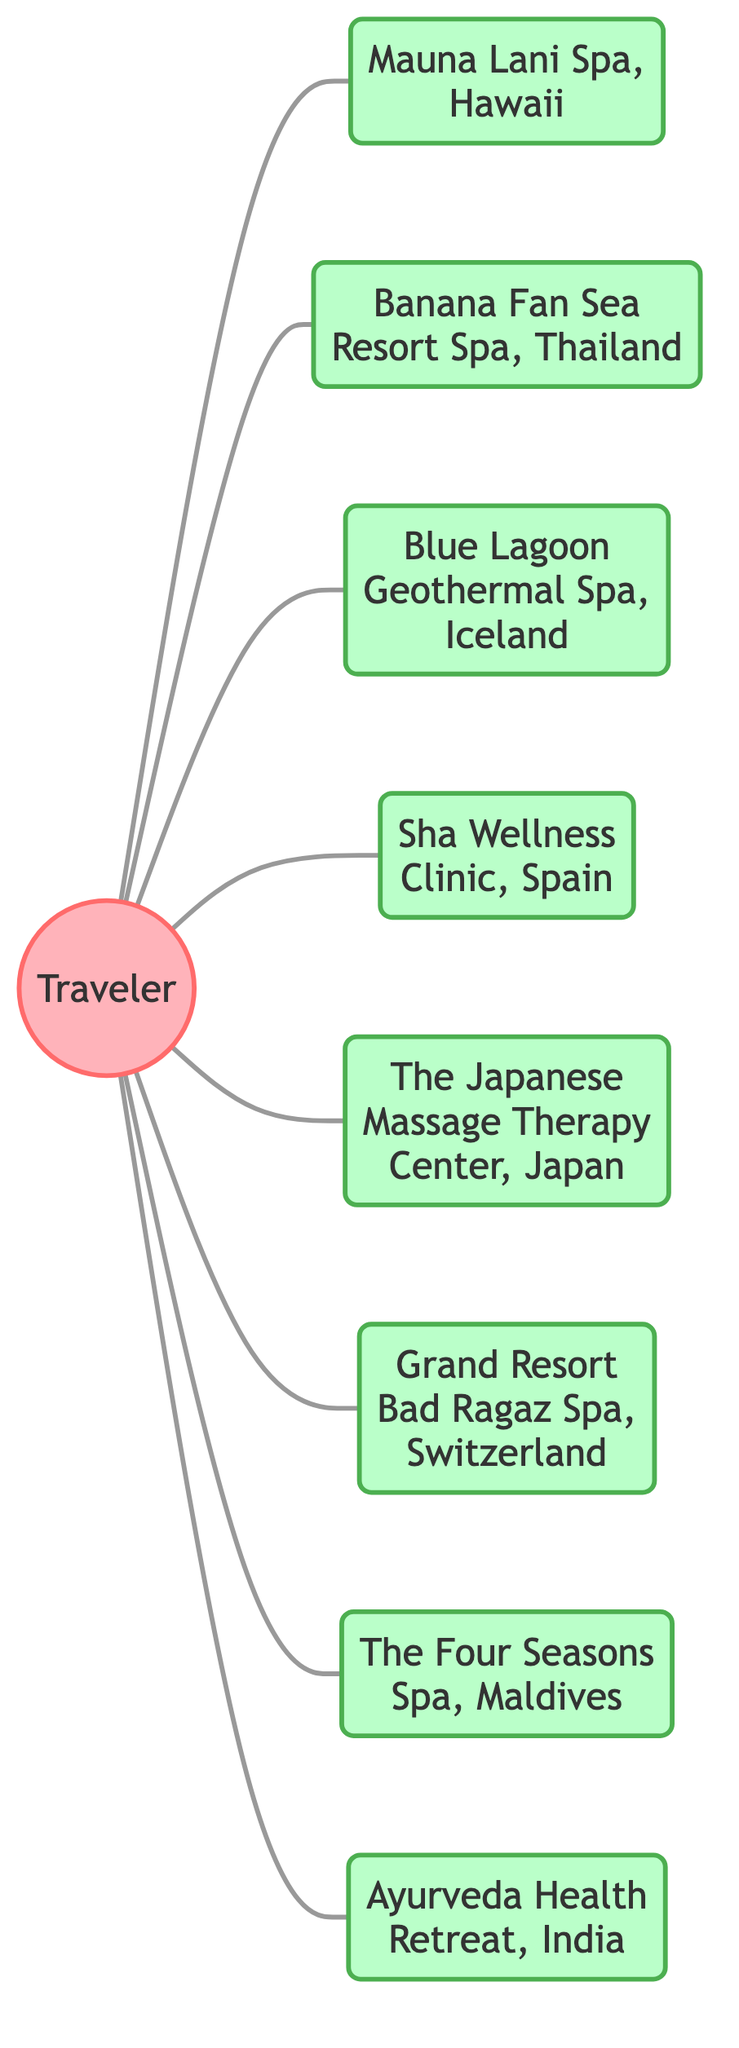What is the total number of relaxation spots visited by the Traveler? The diagram lists 9 relaxation spots that are connected to the Traveler node through the "visited" relationship. Counting these directly gives a total of 9.
Answer: 9 Which relaxation spot is located in Hawaii? The Traveler visited the Mauna Lani Spa, located specifically in Hawaii, represented by node 2.
Answer: Mauna Lani Spa, Hawaii How many edges are connected to the Traveler node? Each relaxation spot that the Traveler visited is represented by an edge connecting to the Traveler node. Since there are 9 relaxation spots, there are also 9 edges.
Answer: 9 What are the names of the two spas visited in Asia? The two spas in Asia are the Banana Fan Sea Resort Spa in Thailand (node 3) and The Japanese Massage Therapy Center in Japan (node 6). The Traveler node connects to both of these spas.
Answer: Banana Fan Sea Resort Spa, The Japanese Massage Therapy Center Which spa is visited that specifically focuses on Ayurveda? The Ayurveda Health Retreat in India (node 9) is the spa that focuses on Ayurveda, and it is connected directly to the Traveler node as well.
Answer: Ayurveda Health Retreat, India Which relaxation spot visited is located in Iceland? The Blue Lagoon Geothermal Spa is the relaxation spot that is located in Iceland, indicated by node 4.
Answer: Blue Lagoon Geothermal Spa, Iceland How many spas are located in Europe? The Grand Resort Bad Ragaz Spa in Switzerland (node 7) and Sha Wellness Clinic in Spain (node 5) are the two spas located in Europe, making a total of 2.
Answer: 2 Which relaxation center is farthest east in the diagram? The Japanese Massage Therapy Center in Japan is the farthest east relaxation center visited, shown by node 6.
Answer: The Japanese Massage Therapy Center, Japan What is the relationship type connecting the Traveler to each spa? The connection type between the Traveler and each spa is described as "visited.” This relationship indicates that the Traveler has been to all listed spas.
Answer: visited 